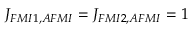Convert formula to latex. <formula><loc_0><loc_0><loc_500><loc_500>J _ { F M I 1 , A F M I } = J _ { F M I 2 , A F M I } = 1</formula> 